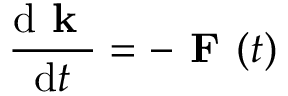<formula> <loc_0><loc_0><loc_500><loc_500>\frac { d k } { d t } = - F ( t )</formula> 